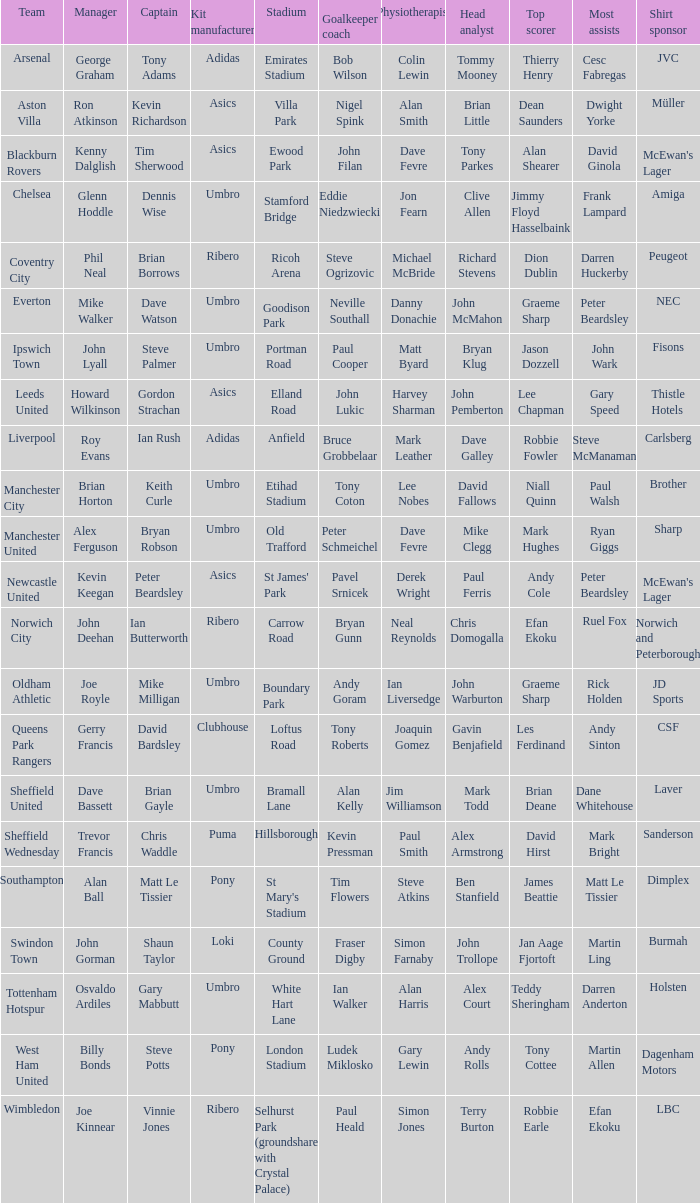Which manager has sheffield wednesday as the team? Trevor Francis. 